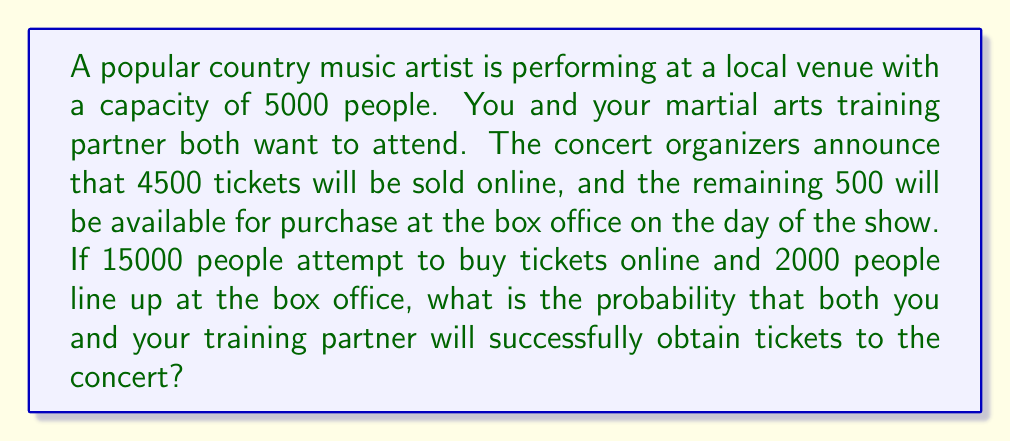Solve this math problem. Let's break this down step-by-step:

1) First, let's calculate the probability of getting an online ticket:
   $P(\text{online ticket}) = \frac{\text{Available online tickets}}{\text{People attempting to buy online}} = \frac{4500}{15000} = 0.3$

2) Now, the probability of getting a box office ticket:
   $P(\text{box office ticket}) = \frac{\text{Available box office tickets}}{\text{People lining up at box office}} = \frac{500}{2000} = 0.25$

3) The probability of not getting an online ticket:
   $P(\text{no online ticket}) = 1 - P(\text{online ticket}) = 1 - 0.3 = 0.7$

4) For both you and your partner to get tickets, there are three possible scenarios:
   a) Both get online tickets
   b) You get an online ticket, your partner gets a box office ticket
   c) Your partner gets an online ticket, you get a box office ticket

5) Probability of both getting online tickets:
   $P(\text{both online}) = 0.3 \times 0.3 = 0.09$

6) Probability of you getting online ticket and partner getting box office ticket:
   $P(\text{you online, partner box office}) = 0.3 \times 0.7 \times 0.25 = 0.0525$

7) Probability of partner getting online ticket and you getting box office ticket:
   $P(\text{partner online, you box office}) = 0.3 \times 0.7 \times 0.25 = 0.0525$

8) The total probability is the sum of these three scenarios:
   $P(\text{both get tickets}) = 0.09 + 0.0525 + 0.0525 = 0.195$

Therefore, the probability that both you and your training partner will successfully obtain tickets is 0.195 or 19.5%.
Answer: 0.195 